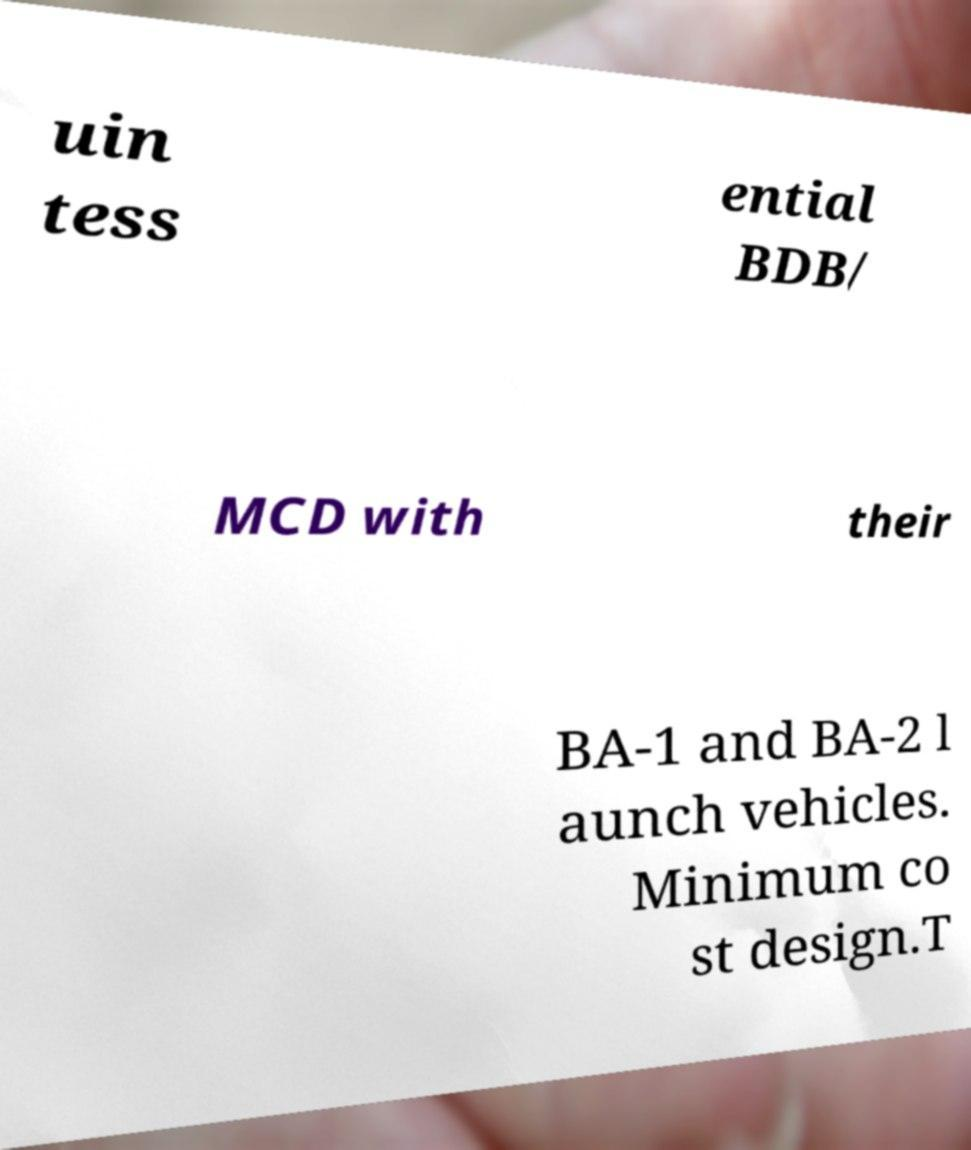For documentation purposes, I need the text within this image transcribed. Could you provide that? uin tess ential BDB/ MCD with their BA-1 and BA-2 l aunch vehicles. Minimum co st design.T 